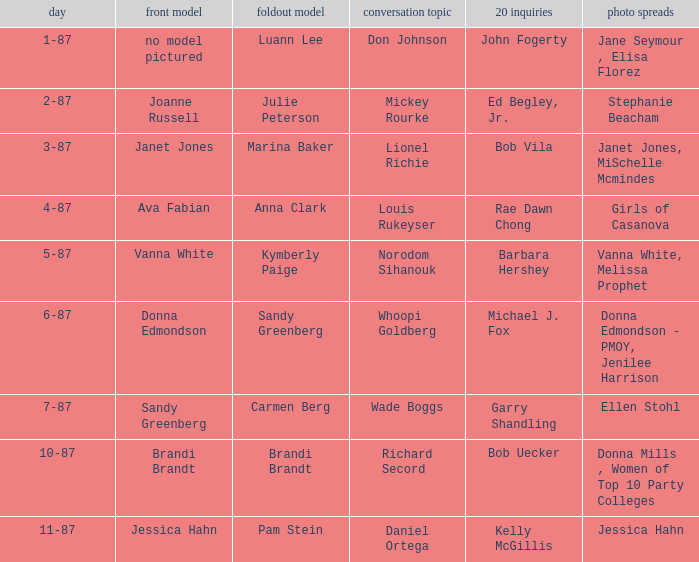Who was the on the cover when Bob Vila did the 20 Questions? Janet Jones. 